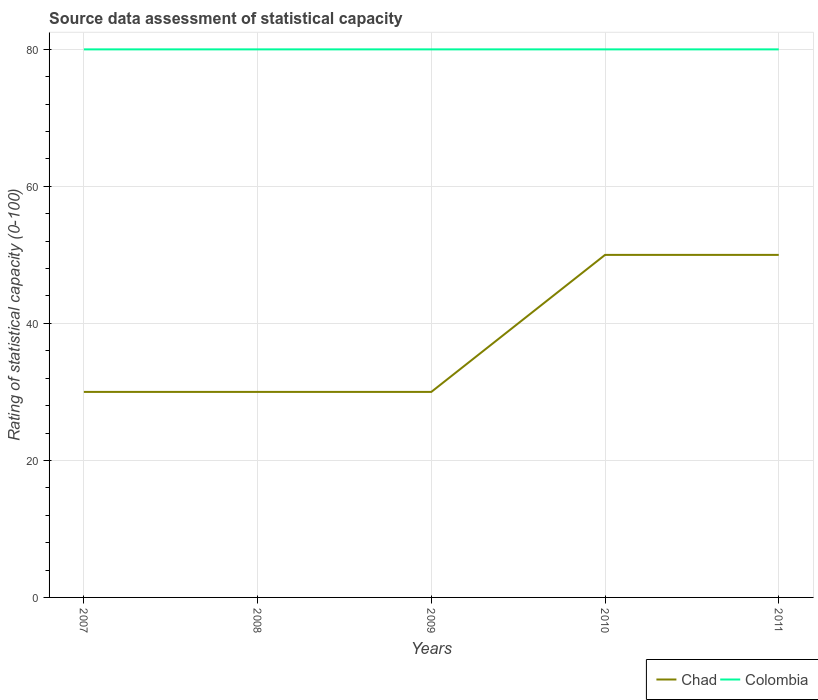Does the line corresponding to Chad intersect with the line corresponding to Colombia?
Make the answer very short. No. Across all years, what is the maximum rating of statistical capacity in Colombia?
Provide a short and direct response. 80. In which year was the rating of statistical capacity in Colombia maximum?
Provide a short and direct response. 2007. What is the difference between the highest and the second highest rating of statistical capacity in Chad?
Ensure brevity in your answer.  20. Is the rating of statistical capacity in Colombia strictly greater than the rating of statistical capacity in Chad over the years?
Your response must be concise. No. What is the difference between two consecutive major ticks on the Y-axis?
Offer a terse response. 20. Does the graph contain grids?
Keep it short and to the point. Yes. Where does the legend appear in the graph?
Offer a terse response. Bottom right. How are the legend labels stacked?
Give a very brief answer. Horizontal. What is the title of the graph?
Make the answer very short. Source data assessment of statistical capacity. What is the label or title of the X-axis?
Offer a very short reply. Years. What is the label or title of the Y-axis?
Ensure brevity in your answer.  Rating of statistical capacity (0-100). What is the Rating of statistical capacity (0-100) in Colombia in 2008?
Ensure brevity in your answer.  80. What is the Rating of statistical capacity (0-100) of Chad in 2009?
Your answer should be compact. 30. What is the Rating of statistical capacity (0-100) of Chad in 2011?
Provide a short and direct response. 50. What is the Rating of statistical capacity (0-100) of Colombia in 2011?
Your answer should be very brief. 80. Across all years, what is the maximum Rating of statistical capacity (0-100) in Chad?
Offer a terse response. 50. Across all years, what is the maximum Rating of statistical capacity (0-100) of Colombia?
Your response must be concise. 80. Across all years, what is the minimum Rating of statistical capacity (0-100) of Chad?
Offer a very short reply. 30. Across all years, what is the minimum Rating of statistical capacity (0-100) in Colombia?
Offer a very short reply. 80. What is the total Rating of statistical capacity (0-100) of Chad in the graph?
Offer a terse response. 190. What is the total Rating of statistical capacity (0-100) in Colombia in the graph?
Provide a short and direct response. 400. What is the difference between the Rating of statistical capacity (0-100) of Chad in 2007 and that in 2008?
Offer a very short reply. 0. What is the difference between the Rating of statistical capacity (0-100) of Colombia in 2007 and that in 2008?
Give a very brief answer. 0. What is the difference between the Rating of statistical capacity (0-100) of Chad in 2007 and that in 2009?
Your answer should be compact. 0. What is the difference between the Rating of statistical capacity (0-100) in Colombia in 2007 and that in 2010?
Provide a short and direct response. 0. What is the difference between the Rating of statistical capacity (0-100) in Chad in 2007 and that in 2011?
Make the answer very short. -20. What is the difference between the Rating of statistical capacity (0-100) of Chad in 2008 and that in 2009?
Your answer should be very brief. 0. What is the difference between the Rating of statistical capacity (0-100) in Colombia in 2008 and that in 2009?
Keep it short and to the point. 0. What is the difference between the Rating of statistical capacity (0-100) in Chad in 2008 and that in 2010?
Keep it short and to the point. -20. What is the difference between the Rating of statistical capacity (0-100) of Chad in 2009 and that in 2010?
Your answer should be compact. -20. What is the difference between the Rating of statistical capacity (0-100) in Colombia in 2009 and that in 2011?
Offer a terse response. 0. What is the difference between the Rating of statistical capacity (0-100) of Chad in 2007 and the Rating of statistical capacity (0-100) of Colombia in 2008?
Provide a short and direct response. -50. What is the difference between the Rating of statistical capacity (0-100) of Chad in 2007 and the Rating of statistical capacity (0-100) of Colombia in 2009?
Give a very brief answer. -50. What is the difference between the Rating of statistical capacity (0-100) of Chad in 2007 and the Rating of statistical capacity (0-100) of Colombia in 2010?
Offer a very short reply. -50. What is the difference between the Rating of statistical capacity (0-100) of Chad in 2008 and the Rating of statistical capacity (0-100) of Colombia in 2009?
Provide a succinct answer. -50. What is the difference between the Rating of statistical capacity (0-100) in Chad in 2010 and the Rating of statistical capacity (0-100) in Colombia in 2011?
Your answer should be compact. -30. What is the average Rating of statistical capacity (0-100) in Colombia per year?
Offer a terse response. 80. In the year 2008, what is the difference between the Rating of statistical capacity (0-100) of Chad and Rating of statistical capacity (0-100) of Colombia?
Ensure brevity in your answer.  -50. In the year 2009, what is the difference between the Rating of statistical capacity (0-100) in Chad and Rating of statistical capacity (0-100) in Colombia?
Keep it short and to the point. -50. In the year 2011, what is the difference between the Rating of statistical capacity (0-100) of Chad and Rating of statistical capacity (0-100) of Colombia?
Provide a succinct answer. -30. What is the ratio of the Rating of statistical capacity (0-100) in Chad in 2007 to that in 2008?
Your answer should be very brief. 1. What is the ratio of the Rating of statistical capacity (0-100) in Colombia in 2007 to that in 2009?
Make the answer very short. 1. What is the ratio of the Rating of statistical capacity (0-100) in Chad in 2008 to that in 2009?
Give a very brief answer. 1. What is the ratio of the Rating of statistical capacity (0-100) in Chad in 2008 to that in 2011?
Keep it short and to the point. 0.6. What is the ratio of the Rating of statistical capacity (0-100) in Colombia in 2008 to that in 2011?
Your answer should be compact. 1. What is the ratio of the Rating of statistical capacity (0-100) of Chad in 2009 to that in 2011?
Ensure brevity in your answer.  0.6. What is the ratio of the Rating of statistical capacity (0-100) of Chad in 2010 to that in 2011?
Provide a short and direct response. 1. What is the difference between the highest and the second highest Rating of statistical capacity (0-100) in Chad?
Your answer should be very brief. 0. What is the difference between the highest and the second highest Rating of statistical capacity (0-100) of Colombia?
Your answer should be very brief. 0. What is the difference between the highest and the lowest Rating of statistical capacity (0-100) of Colombia?
Give a very brief answer. 0. 